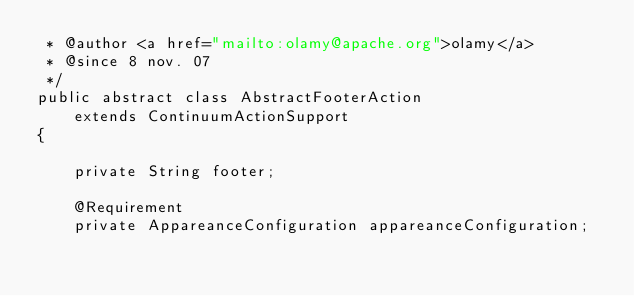Convert code to text. <code><loc_0><loc_0><loc_500><loc_500><_Java_> * @author <a href="mailto:olamy@apache.org">olamy</a>
 * @since 8 nov. 07
 */
public abstract class AbstractFooterAction
    extends ContinuumActionSupport
{

    private String footer;

    @Requirement
    private AppareanceConfiguration appareanceConfiguration;
</code> 